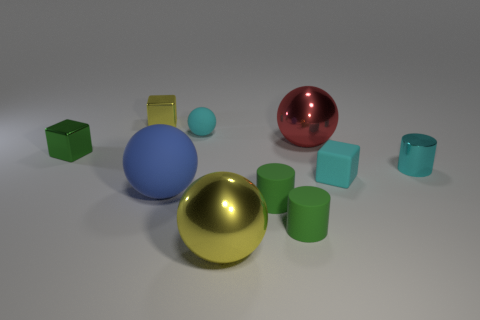Subtract all spheres. How many objects are left? 6 Add 5 tiny blocks. How many tiny blocks exist? 8 Subtract 1 green blocks. How many objects are left? 9 Subtract all tiny cyan metal spheres. Subtract all big matte things. How many objects are left? 9 Add 1 cyan rubber spheres. How many cyan rubber spheres are left? 2 